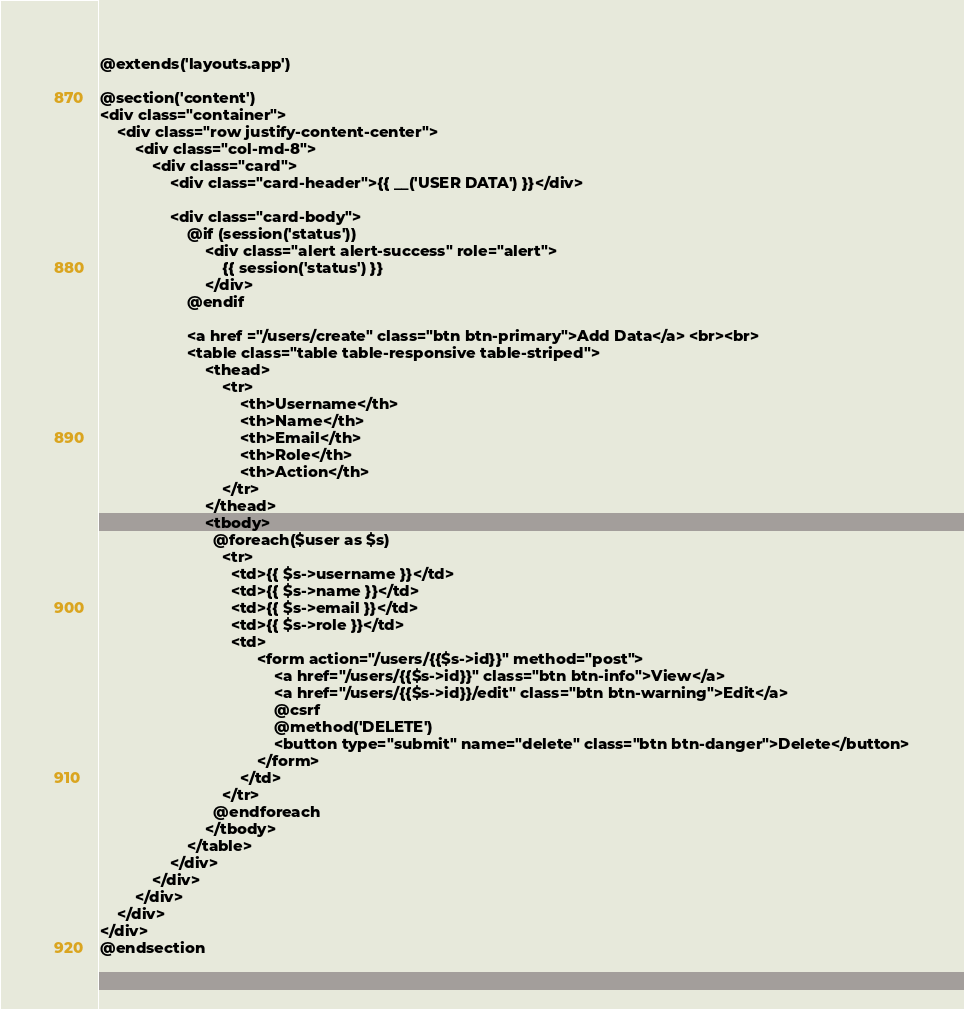Convert code to text. <code><loc_0><loc_0><loc_500><loc_500><_PHP_>@extends('layouts.app')

@section('content')
<div class="container">
    <div class="row justify-content-center">
        <div class="col-md-8">
            <div class="card">
                <div class="card-header">{{ __('USER DATA') }}</div>

                <div class="card-body">
                    @if (session('status'))
                        <div class="alert alert-success" role="alert">
                            {{ session('status') }}
                        </div>
                    @endif

                    <a href ="/users/create" class="btn btn-primary">Add Data</a> <br><br>
                    <table class="table table-responsive table-striped">
                        <thead>
                            <tr>
                                <th>Username</th>
                                <th>Name</th>
                                <th>Email</th>
                                <th>Role</th>
                                <th>Action</th>
                            </tr>
                        </thead>
                        <tbody>
                          @foreach($user as $s)
                            <tr>
                              <td>{{ $s->username }}</td>
                              <td>{{ $s->name }}</td>
                              <td>{{ $s->email }}</td>
                              <td>{{ $s->role }}</td>
                              <td>
                                    <form action="/users/{{$s->id}}" method="post">
                                        <a href="/users/{{$s->id}}" class="btn btn-info">View</a>
                                        <a href="/users/{{$s->id}}/edit" class="btn btn-warning">Edit</a>
                                        @csrf
                                        @method('DELETE')
                                        <button type="submit" name="delete" class="btn btn-danger">Delete</button>
                                    </form>
                                </td>
                            </tr> 
                          @endforeach 
                        </tbody>
                    </table>
                </div>
            </div>
        </div>
    </div>
</div>
@endsection</code> 